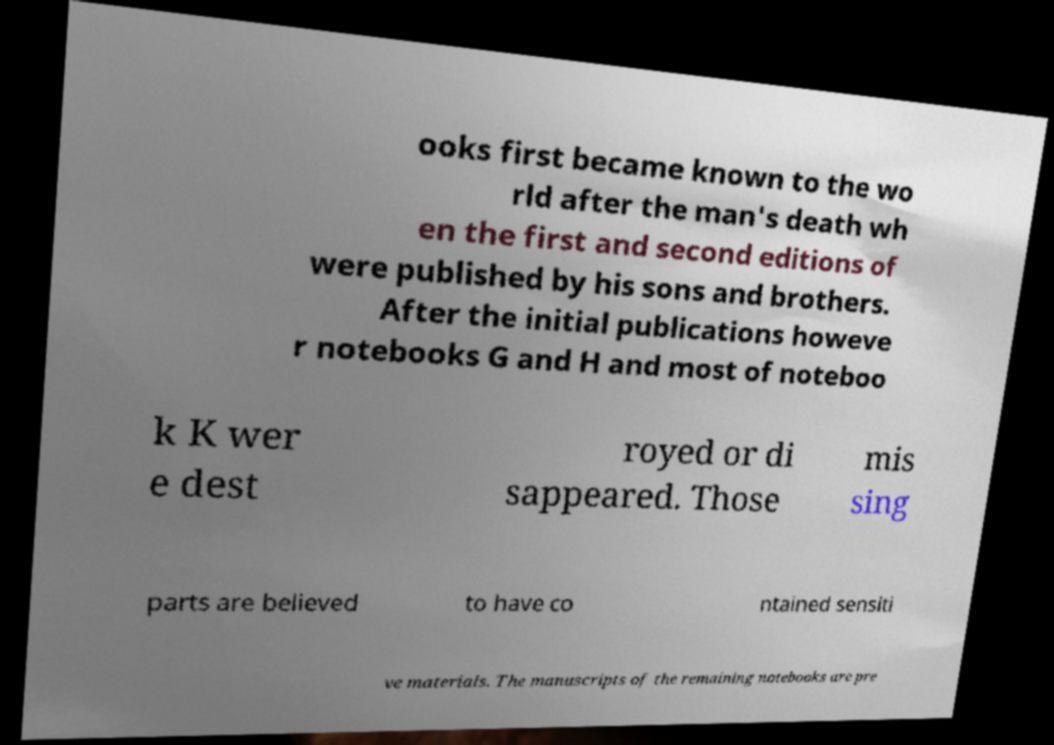Could you extract and type out the text from this image? ooks first became known to the wo rld after the man's death wh en the first and second editions of were published by his sons and brothers. After the initial publications howeve r notebooks G and H and most of noteboo k K wer e dest royed or di sappeared. Those mis sing parts are believed to have co ntained sensiti ve materials. The manuscripts of the remaining notebooks are pre 